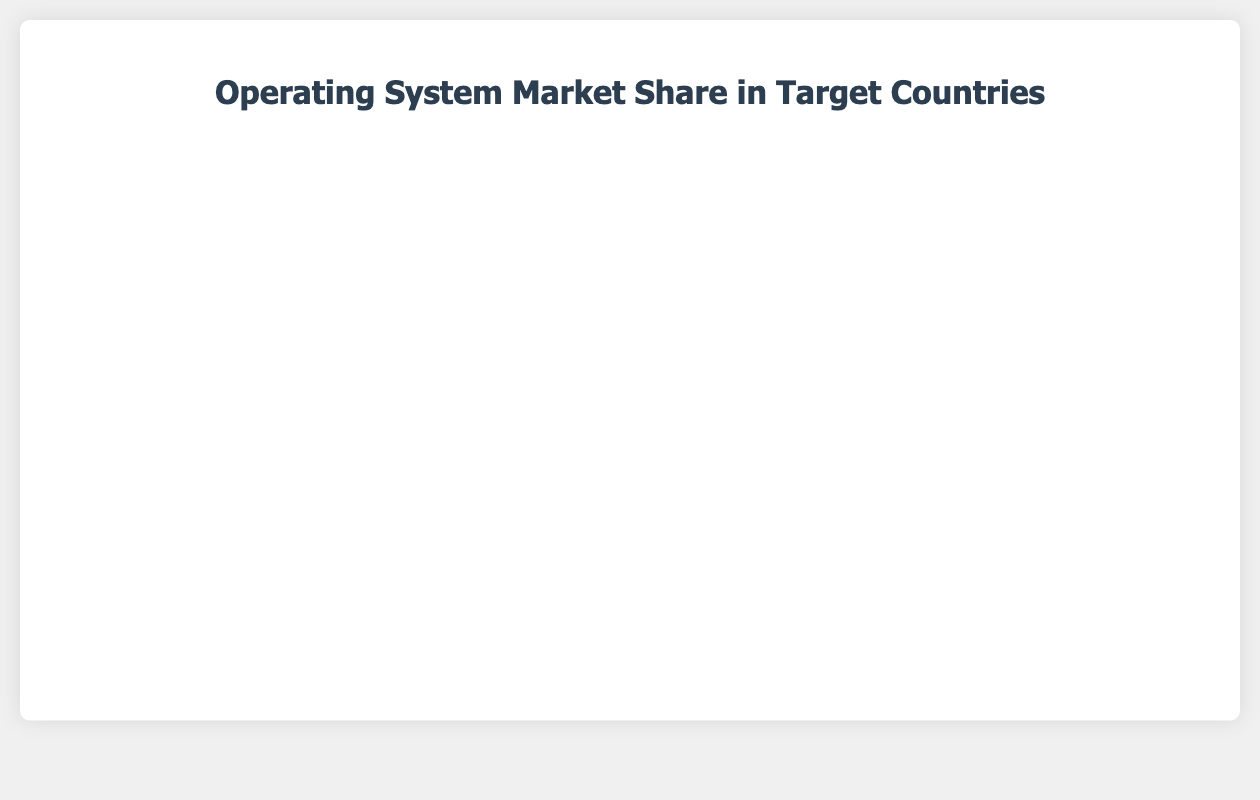How does the market share of macOS in Japan compare to that in the United States? The market share of macOS in Japan is 30%, and in the United States, it is also 30%. Since both are equal, macOS has the same market share in both Japan and the United States.
Answer: 30% vs 30% Which country has the lowest market share for Linux? To find the country with the lowest market share for Linux, compare the Linux percentages: United States (5%), Germany (8%), Japan (10%), India (15%), Brazil (10%). The United States has the lowest at 5%.
Answer: United States What is the sum of the market shares of Chrome OS in India and Brazil? The market share of Chrome OS in India is 3%, and in Brazil, it is also 3%. Summing these figures gives 3% + 3% = 6%.
Answer: 6% Which country has the highest market share for Windows? Compare the Windows market share across all countries: United States (55%), Germany (60%), Japan (50%), India (70%), Brazil (65%). India has the highest at 70%.
Answer: India What is the average market share of Other operating systems across all countries? The Other market share in each country is: United States (3%), Germany (2%), Japan (5%), India (2%), Brazil (2%). Sum these and divide by the number of countries: (3 + 2 + 5 + 2 + 2) / 5 = 14 / 5 = 2.8%.
Answer: 2.8% Compare the combined market share of Linux and Chrome OS in Japan to that in Germany. The combined market share of Linux and Chrome OS in Japan is 10% + 5% = 15%, while in Germany it is 8% + 5% = 13%. Hence, Japan has a higher combined market share for Linux and Chrome OS.
Answer: 15% vs 13% What is the difference in the market share of macOS between Germany and India? The market share of macOS in Germany is 25%, and in India, it is 10%. The difference is 25% - 10% = 15%.
Answer: 15% Which operating system has the smallest market share in Germany? In Germany, the market shares are: Windows (60%), macOS (25%), Linux (8%), Chrome OS (5%), Other (2%). The smallest market share is for Other at 2%.
Answer: Other If you combine the market shares of Chrome OS and Other across all countries, which country has the highest total? Summing Chrome OS and Other for each country: 
United States: 7% + 3% = 10%
Germany: 5% + 2% = 7%
Japan: 5% + 5% = 10%
India: 3% + 2% = 5%
Brazil: 3% + 2% = 5%
The United States and Japan both have the highest total at 10%.
Answer: United States and Japan 